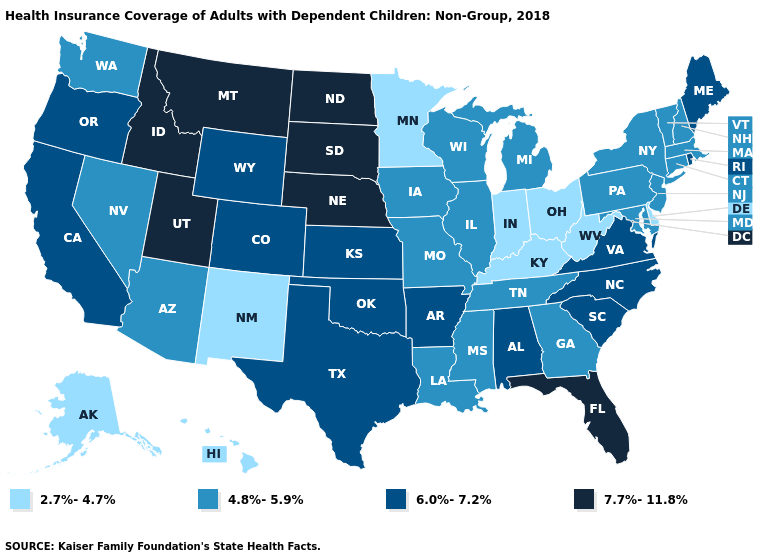Name the states that have a value in the range 6.0%-7.2%?
Short answer required. Alabama, Arkansas, California, Colorado, Kansas, Maine, North Carolina, Oklahoma, Oregon, Rhode Island, South Carolina, Texas, Virginia, Wyoming. Does Arkansas have the lowest value in the South?
Keep it brief. No. What is the value of Vermont?
Answer briefly. 4.8%-5.9%. Name the states that have a value in the range 6.0%-7.2%?
Quick response, please. Alabama, Arkansas, California, Colorado, Kansas, Maine, North Carolina, Oklahoma, Oregon, Rhode Island, South Carolina, Texas, Virginia, Wyoming. What is the value of Vermont?
Write a very short answer. 4.8%-5.9%. Does North Dakota have the highest value in the MidWest?
Be succinct. Yes. Name the states that have a value in the range 6.0%-7.2%?
Quick response, please. Alabama, Arkansas, California, Colorado, Kansas, Maine, North Carolina, Oklahoma, Oregon, Rhode Island, South Carolina, Texas, Virginia, Wyoming. Does Kentucky have the lowest value in the USA?
Be succinct. Yes. What is the value of Utah?
Short answer required. 7.7%-11.8%. Among the states that border Arkansas , does Texas have the highest value?
Write a very short answer. Yes. What is the value of Ohio?
Give a very brief answer. 2.7%-4.7%. What is the lowest value in the USA?
Write a very short answer. 2.7%-4.7%. What is the lowest value in states that border Michigan?
Concise answer only. 2.7%-4.7%. Does Indiana have the lowest value in the USA?
Quick response, please. Yes. 